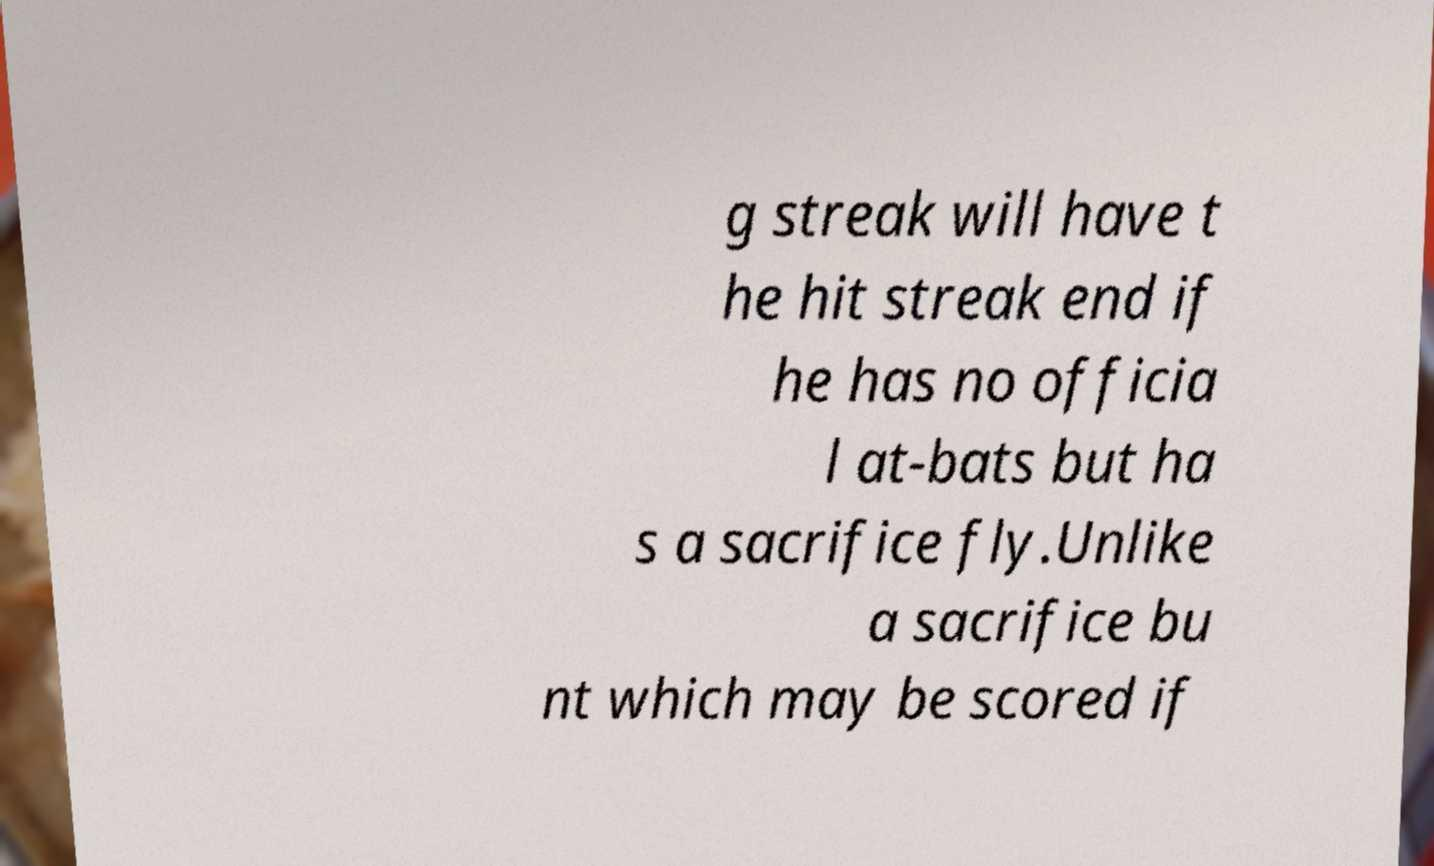Please identify and transcribe the text found in this image. g streak will have t he hit streak end if he has no officia l at-bats but ha s a sacrifice fly.Unlike a sacrifice bu nt which may be scored if 